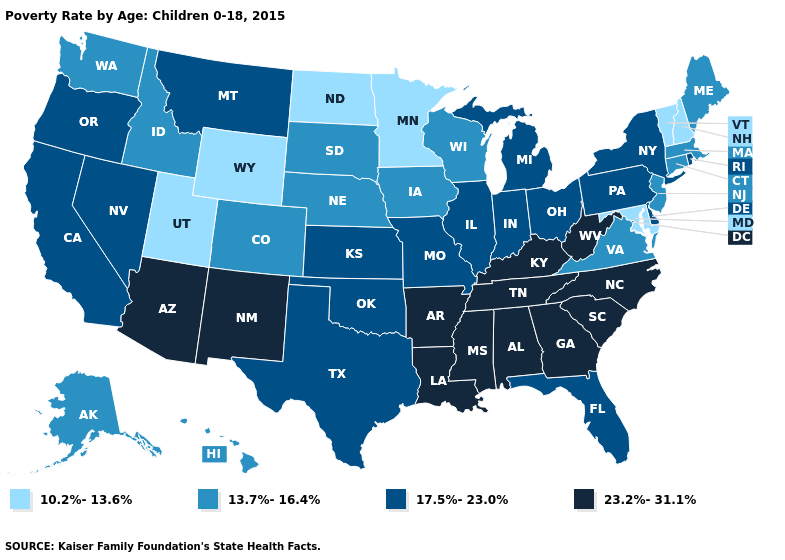Which states hav the highest value in the West?
Quick response, please. Arizona, New Mexico. Does the first symbol in the legend represent the smallest category?
Give a very brief answer. Yes. Among the states that border Utah , does New Mexico have the highest value?
Keep it brief. Yes. Which states have the lowest value in the USA?
Short answer required. Maryland, Minnesota, New Hampshire, North Dakota, Utah, Vermont, Wyoming. What is the value of Virginia?
Be succinct. 13.7%-16.4%. Name the states that have a value in the range 17.5%-23.0%?
Short answer required. California, Delaware, Florida, Illinois, Indiana, Kansas, Michigan, Missouri, Montana, Nevada, New York, Ohio, Oklahoma, Oregon, Pennsylvania, Rhode Island, Texas. Does the first symbol in the legend represent the smallest category?
Answer briefly. Yes. Does the first symbol in the legend represent the smallest category?
Give a very brief answer. Yes. What is the value of Georgia?
Keep it brief. 23.2%-31.1%. Does Wyoming have the same value as Nevada?
Answer briefly. No. What is the value of Kentucky?
Quick response, please. 23.2%-31.1%. What is the value of Minnesota?
Be succinct. 10.2%-13.6%. Among the states that border South Carolina , which have the highest value?
Keep it brief. Georgia, North Carolina. What is the value of Connecticut?
Quick response, please. 13.7%-16.4%. How many symbols are there in the legend?
Concise answer only. 4. 